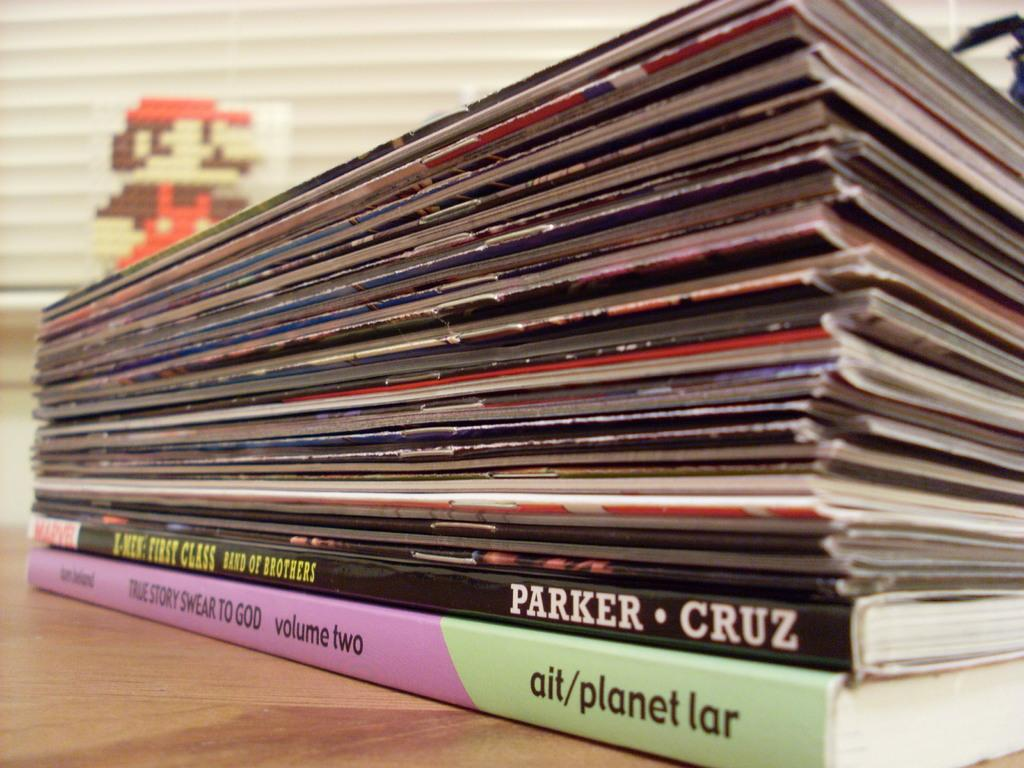Provide a one-sentence caption for the provided image. A stack of magazine with two books on the bottom which one book is titled True Story Swear To God. 